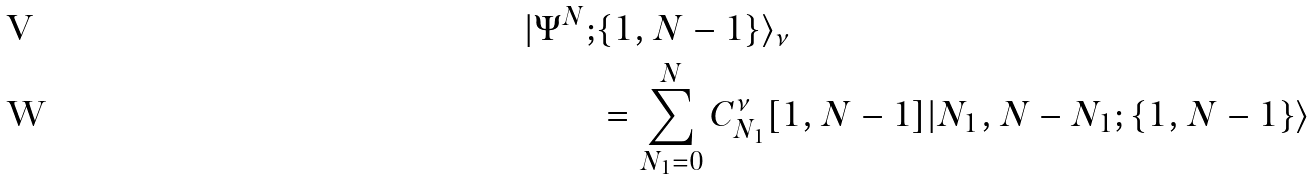<formula> <loc_0><loc_0><loc_500><loc_500>| \Psi ^ { N } ; & \{ 1 , N - 1 \} \rangle _ { \nu } \\ & = \sum _ { N _ { 1 } = 0 } ^ { N } C ^ { \nu } _ { N _ { 1 } } [ 1 , N - 1 ] | N _ { 1 } , N - N _ { 1 } ; \{ 1 , N - 1 \} \rangle</formula> 